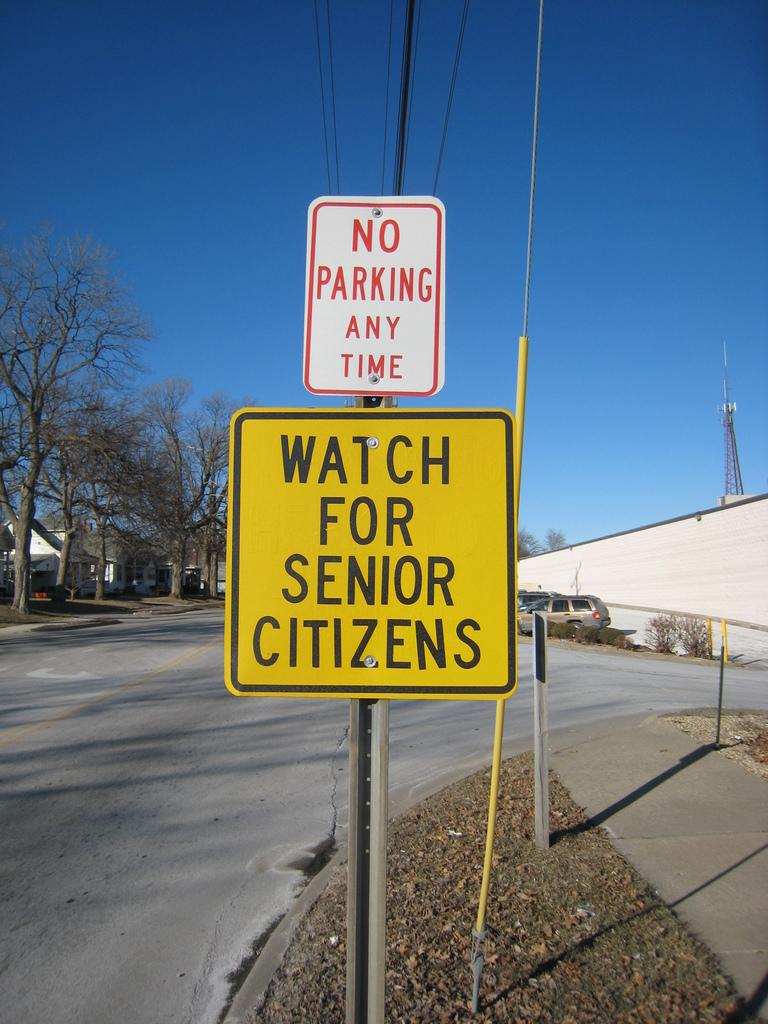Provide a one-sentence caption for the provided image. a No Parking Any Time sign over a Watch for Senior Citizens sign. 